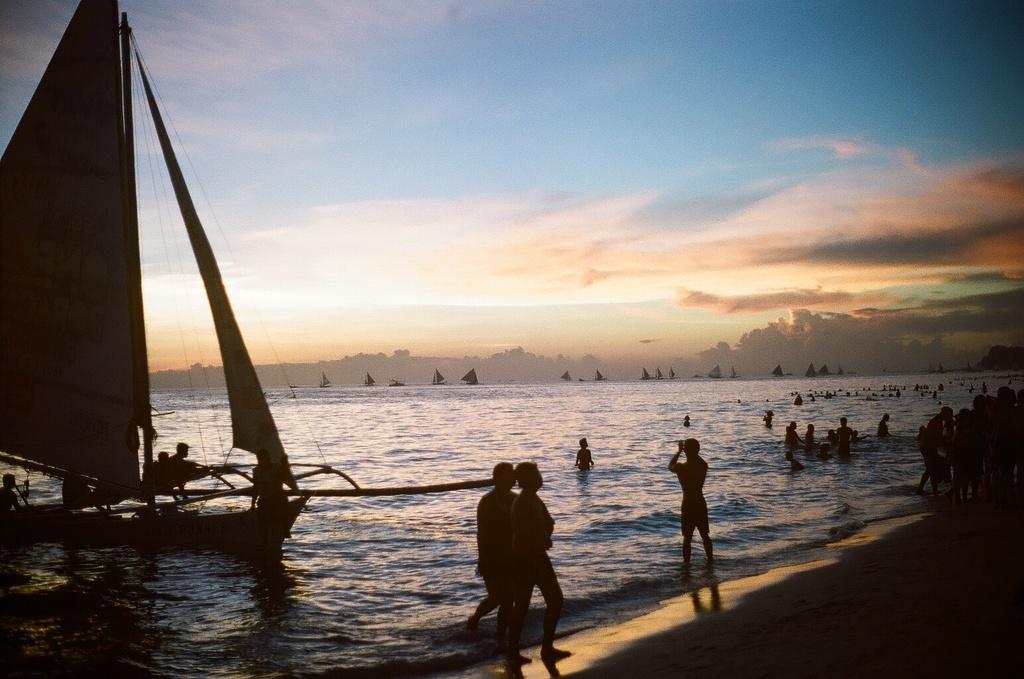Describe this image in one or two sentences. On the right side, there are persons standing near tides of the ocean. On the left side, there is a boat on which, there are persons. And this boat is on the water of an ocean. In the background, there is a mountain and there are clouds in the blue sky. 